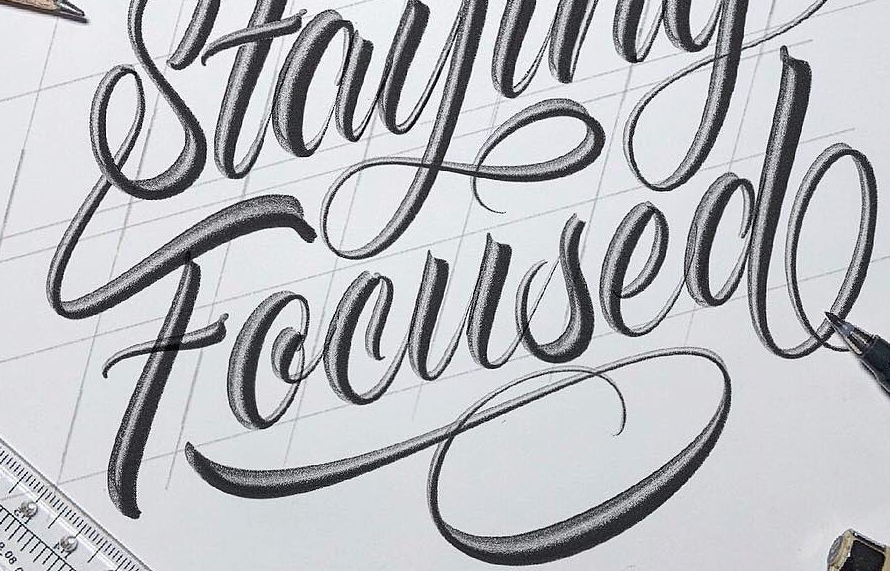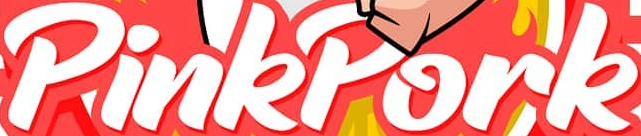What words can you see in these images in sequence, separated by a semicolon? Focused; PinkPork 